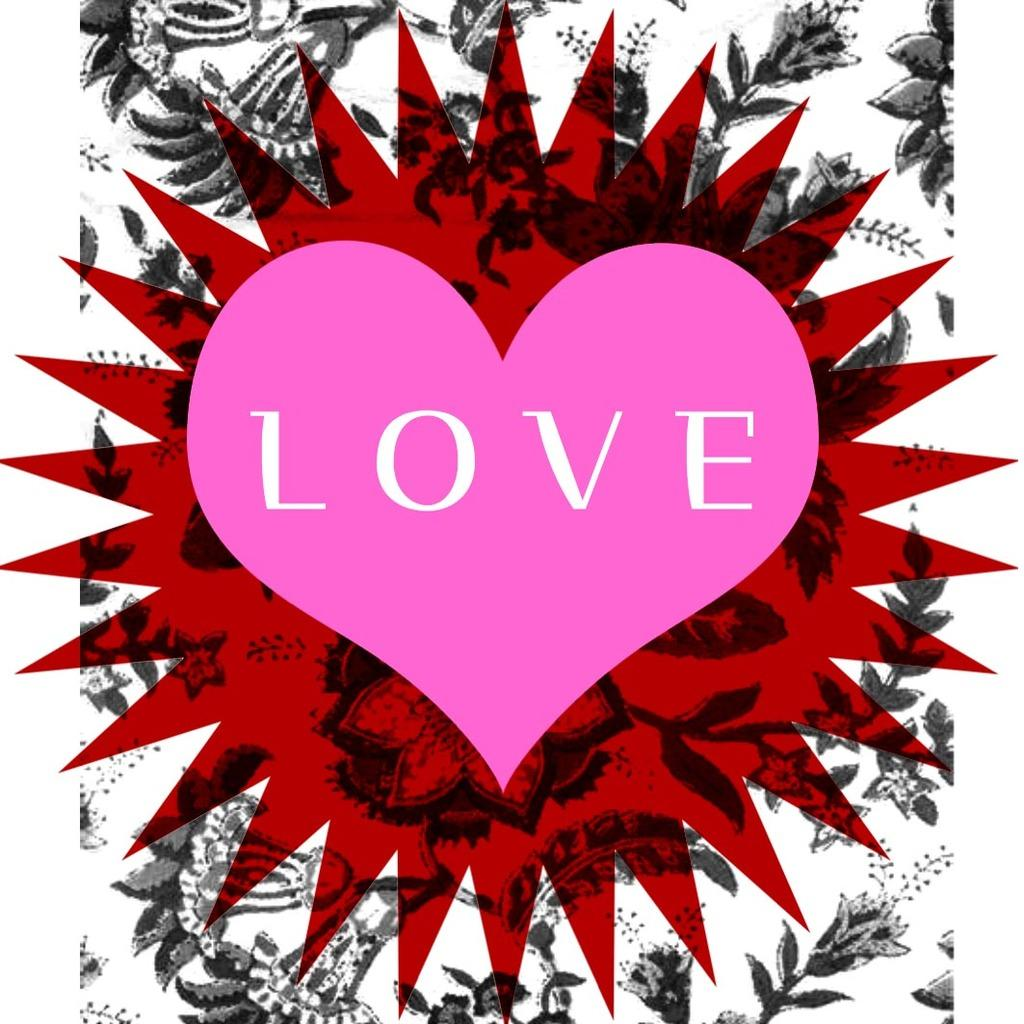What is present on the wall in the image? There is a poster in the image. Can you describe the appearance of the poster? The poster has designs. Is there any text on the poster? Yes, there is writing on the poster. Where are the chickens located in the image? There are no chickens present in the image. What type of servant can be seen working in the garden in the image? There is no servant or garden present in the image. 